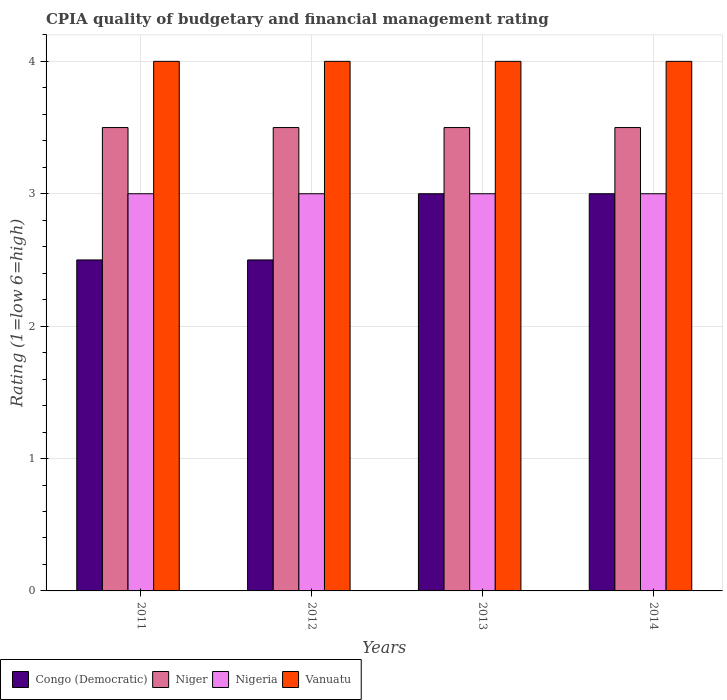Are the number of bars on each tick of the X-axis equal?
Offer a very short reply. Yes. How many bars are there on the 4th tick from the left?
Offer a terse response. 4. What is the label of the 2nd group of bars from the left?
Provide a short and direct response. 2012. Across all years, what is the maximum CPIA rating in Niger?
Provide a succinct answer. 3.5. In which year was the CPIA rating in Nigeria maximum?
Your answer should be very brief. 2011. In which year was the CPIA rating in Congo (Democratic) minimum?
Keep it short and to the point. 2011. What is the total CPIA rating in Congo (Democratic) in the graph?
Make the answer very short. 11. What is the difference between the CPIA rating in Nigeria in 2013 and that in 2014?
Your answer should be compact. 0. What is the difference between the CPIA rating in Congo (Democratic) in 2011 and the CPIA rating in Niger in 2014?
Provide a succinct answer. -1. In the year 2011, what is the difference between the CPIA rating in Nigeria and CPIA rating in Congo (Democratic)?
Your response must be concise. 0.5. What is the ratio of the CPIA rating in Nigeria in 2011 to that in 2012?
Offer a terse response. 1. What is the difference between the highest and the second highest CPIA rating in Nigeria?
Make the answer very short. 0. In how many years, is the CPIA rating in Niger greater than the average CPIA rating in Niger taken over all years?
Offer a very short reply. 0. Is the sum of the CPIA rating in Congo (Democratic) in 2011 and 2013 greater than the maximum CPIA rating in Vanuatu across all years?
Provide a succinct answer. Yes. Is it the case that in every year, the sum of the CPIA rating in Vanuatu and CPIA rating in Niger is greater than the sum of CPIA rating in Nigeria and CPIA rating in Congo (Democratic)?
Your answer should be compact. Yes. What does the 4th bar from the left in 2011 represents?
Provide a succinct answer. Vanuatu. What does the 4th bar from the right in 2011 represents?
Keep it short and to the point. Congo (Democratic). How many bars are there?
Provide a succinct answer. 16. Are all the bars in the graph horizontal?
Offer a very short reply. No. Does the graph contain any zero values?
Provide a short and direct response. No. Where does the legend appear in the graph?
Offer a very short reply. Bottom left. How many legend labels are there?
Keep it short and to the point. 4. What is the title of the graph?
Give a very brief answer. CPIA quality of budgetary and financial management rating. Does "France" appear as one of the legend labels in the graph?
Make the answer very short. No. What is the Rating (1=low 6=high) of Niger in 2011?
Offer a terse response. 3.5. What is the Rating (1=low 6=high) in Nigeria in 2011?
Make the answer very short. 3. What is the Rating (1=low 6=high) of Vanuatu in 2011?
Your answer should be very brief. 4. What is the Rating (1=low 6=high) of Niger in 2012?
Your response must be concise. 3.5. What is the Rating (1=low 6=high) in Niger in 2013?
Make the answer very short. 3.5. What is the Rating (1=low 6=high) in Vanuatu in 2013?
Your response must be concise. 4. What is the Rating (1=low 6=high) in Congo (Democratic) in 2014?
Ensure brevity in your answer.  3. Across all years, what is the maximum Rating (1=low 6=high) in Niger?
Offer a terse response. 3.5. Across all years, what is the maximum Rating (1=low 6=high) of Vanuatu?
Keep it short and to the point. 4. Across all years, what is the minimum Rating (1=low 6=high) in Nigeria?
Give a very brief answer. 3. What is the total Rating (1=low 6=high) in Congo (Democratic) in the graph?
Your response must be concise. 11. What is the total Rating (1=low 6=high) in Nigeria in the graph?
Provide a short and direct response. 12. What is the difference between the Rating (1=low 6=high) of Niger in 2011 and that in 2012?
Give a very brief answer. 0. What is the difference between the Rating (1=low 6=high) in Niger in 2011 and that in 2014?
Provide a short and direct response. 0. What is the difference between the Rating (1=low 6=high) of Nigeria in 2011 and that in 2014?
Offer a very short reply. 0. What is the difference between the Rating (1=low 6=high) in Vanuatu in 2011 and that in 2014?
Your response must be concise. 0. What is the difference between the Rating (1=low 6=high) of Congo (Democratic) in 2012 and that in 2013?
Keep it short and to the point. -0.5. What is the difference between the Rating (1=low 6=high) of Nigeria in 2012 and that in 2013?
Offer a very short reply. 0. What is the difference between the Rating (1=low 6=high) in Vanuatu in 2012 and that in 2013?
Your answer should be very brief. 0. What is the difference between the Rating (1=low 6=high) in Congo (Democratic) in 2012 and that in 2014?
Keep it short and to the point. -0.5. What is the difference between the Rating (1=low 6=high) of Niger in 2012 and that in 2014?
Offer a terse response. 0. What is the difference between the Rating (1=low 6=high) in Vanuatu in 2012 and that in 2014?
Your answer should be compact. 0. What is the difference between the Rating (1=low 6=high) of Congo (Democratic) in 2013 and that in 2014?
Your answer should be compact. 0. What is the difference between the Rating (1=low 6=high) in Niger in 2013 and that in 2014?
Offer a very short reply. 0. What is the difference between the Rating (1=low 6=high) of Nigeria in 2013 and that in 2014?
Ensure brevity in your answer.  0. What is the difference between the Rating (1=low 6=high) of Congo (Democratic) in 2011 and the Rating (1=low 6=high) of Vanuatu in 2012?
Offer a terse response. -1.5. What is the difference between the Rating (1=low 6=high) in Niger in 2011 and the Rating (1=low 6=high) in Nigeria in 2012?
Offer a very short reply. 0.5. What is the difference between the Rating (1=low 6=high) in Congo (Democratic) in 2011 and the Rating (1=low 6=high) in Niger in 2013?
Keep it short and to the point. -1. What is the difference between the Rating (1=low 6=high) in Congo (Democratic) in 2011 and the Rating (1=low 6=high) in Nigeria in 2013?
Keep it short and to the point. -0.5. What is the difference between the Rating (1=low 6=high) of Nigeria in 2011 and the Rating (1=low 6=high) of Vanuatu in 2013?
Provide a succinct answer. -1. What is the difference between the Rating (1=low 6=high) of Congo (Democratic) in 2011 and the Rating (1=low 6=high) of Vanuatu in 2014?
Ensure brevity in your answer.  -1.5. What is the difference between the Rating (1=low 6=high) in Congo (Democratic) in 2012 and the Rating (1=low 6=high) in Nigeria in 2013?
Offer a very short reply. -0.5. What is the difference between the Rating (1=low 6=high) of Congo (Democratic) in 2012 and the Rating (1=low 6=high) of Vanuatu in 2013?
Provide a short and direct response. -1.5. What is the difference between the Rating (1=low 6=high) of Nigeria in 2012 and the Rating (1=low 6=high) of Vanuatu in 2013?
Keep it short and to the point. -1. What is the difference between the Rating (1=low 6=high) of Congo (Democratic) in 2012 and the Rating (1=low 6=high) of Niger in 2014?
Your answer should be compact. -1. What is the difference between the Rating (1=low 6=high) in Niger in 2012 and the Rating (1=low 6=high) in Vanuatu in 2014?
Your answer should be compact. -0.5. What is the difference between the Rating (1=low 6=high) in Congo (Democratic) in 2013 and the Rating (1=low 6=high) in Nigeria in 2014?
Give a very brief answer. 0. What is the difference between the Rating (1=low 6=high) in Niger in 2013 and the Rating (1=low 6=high) in Nigeria in 2014?
Ensure brevity in your answer.  0.5. What is the difference between the Rating (1=low 6=high) of Niger in 2013 and the Rating (1=low 6=high) of Vanuatu in 2014?
Ensure brevity in your answer.  -0.5. What is the average Rating (1=low 6=high) in Congo (Democratic) per year?
Offer a very short reply. 2.75. What is the average Rating (1=low 6=high) in Niger per year?
Your answer should be very brief. 3.5. In the year 2011, what is the difference between the Rating (1=low 6=high) of Congo (Democratic) and Rating (1=low 6=high) of Nigeria?
Provide a short and direct response. -0.5. In the year 2011, what is the difference between the Rating (1=low 6=high) in Congo (Democratic) and Rating (1=low 6=high) in Vanuatu?
Provide a succinct answer. -1.5. In the year 2011, what is the difference between the Rating (1=low 6=high) in Niger and Rating (1=low 6=high) in Nigeria?
Ensure brevity in your answer.  0.5. In the year 2011, what is the difference between the Rating (1=low 6=high) of Niger and Rating (1=low 6=high) of Vanuatu?
Your response must be concise. -0.5. In the year 2012, what is the difference between the Rating (1=low 6=high) in Congo (Democratic) and Rating (1=low 6=high) in Niger?
Offer a very short reply. -1. In the year 2012, what is the difference between the Rating (1=low 6=high) of Congo (Democratic) and Rating (1=low 6=high) of Vanuatu?
Provide a succinct answer. -1.5. In the year 2012, what is the difference between the Rating (1=low 6=high) in Niger and Rating (1=low 6=high) in Nigeria?
Provide a succinct answer. 0.5. In the year 2012, what is the difference between the Rating (1=low 6=high) of Niger and Rating (1=low 6=high) of Vanuatu?
Offer a very short reply. -0.5. In the year 2012, what is the difference between the Rating (1=low 6=high) of Nigeria and Rating (1=low 6=high) of Vanuatu?
Make the answer very short. -1. In the year 2013, what is the difference between the Rating (1=low 6=high) of Congo (Democratic) and Rating (1=low 6=high) of Niger?
Ensure brevity in your answer.  -0.5. In the year 2013, what is the difference between the Rating (1=low 6=high) of Congo (Democratic) and Rating (1=low 6=high) of Nigeria?
Provide a short and direct response. 0. In the year 2013, what is the difference between the Rating (1=low 6=high) in Congo (Democratic) and Rating (1=low 6=high) in Vanuatu?
Offer a terse response. -1. In the year 2014, what is the difference between the Rating (1=low 6=high) in Congo (Democratic) and Rating (1=low 6=high) in Niger?
Give a very brief answer. -0.5. In the year 2014, what is the difference between the Rating (1=low 6=high) in Niger and Rating (1=low 6=high) in Nigeria?
Provide a short and direct response. 0.5. What is the ratio of the Rating (1=low 6=high) of Congo (Democratic) in 2011 to that in 2013?
Your answer should be very brief. 0.83. What is the ratio of the Rating (1=low 6=high) in Niger in 2011 to that in 2013?
Ensure brevity in your answer.  1. What is the ratio of the Rating (1=low 6=high) in Nigeria in 2011 to that in 2014?
Your answer should be very brief. 1. What is the ratio of the Rating (1=low 6=high) in Vanuatu in 2011 to that in 2014?
Your response must be concise. 1. What is the ratio of the Rating (1=low 6=high) of Congo (Democratic) in 2012 to that in 2013?
Your answer should be compact. 0.83. What is the ratio of the Rating (1=low 6=high) of Niger in 2012 to that in 2013?
Give a very brief answer. 1. What is the ratio of the Rating (1=low 6=high) in Nigeria in 2012 to that in 2013?
Your response must be concise. 1. What is the ratio of the Rating (1=low 6=high) of Nigeria in 2012 to that in 2014?
Provide a succinct answer. 1. What is the difference between the highest and the second highest Rating (1=low 6=high) of Nigeria?
Make the answer very short. 0. What is the difference between the highest and the second highest Rating (1=low 6=high) of Vanuatu?
Provide a succinct answer. 0. What is the difference between the highest and the lowest Rating (1=low 6=high) in Congo (Democratic)?
Give a very brief answer. 0.5. What is the difference between the highest and the lowest Rating (1=low 6=high) in Niger?
Your answer should be compact. 0. What is the difference between the highest and the lowest Rating (1=low 6=high) of Nigeria?
Give a very brief answer. 0. What is the difference between the highest and the lowest Rating (1=low 6=high) in Vanuatu?
Offer a terse response. 0. 